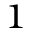<formula> <loc_0><loc_0><loc_500><loc_500>^ { 1 }</formula> 